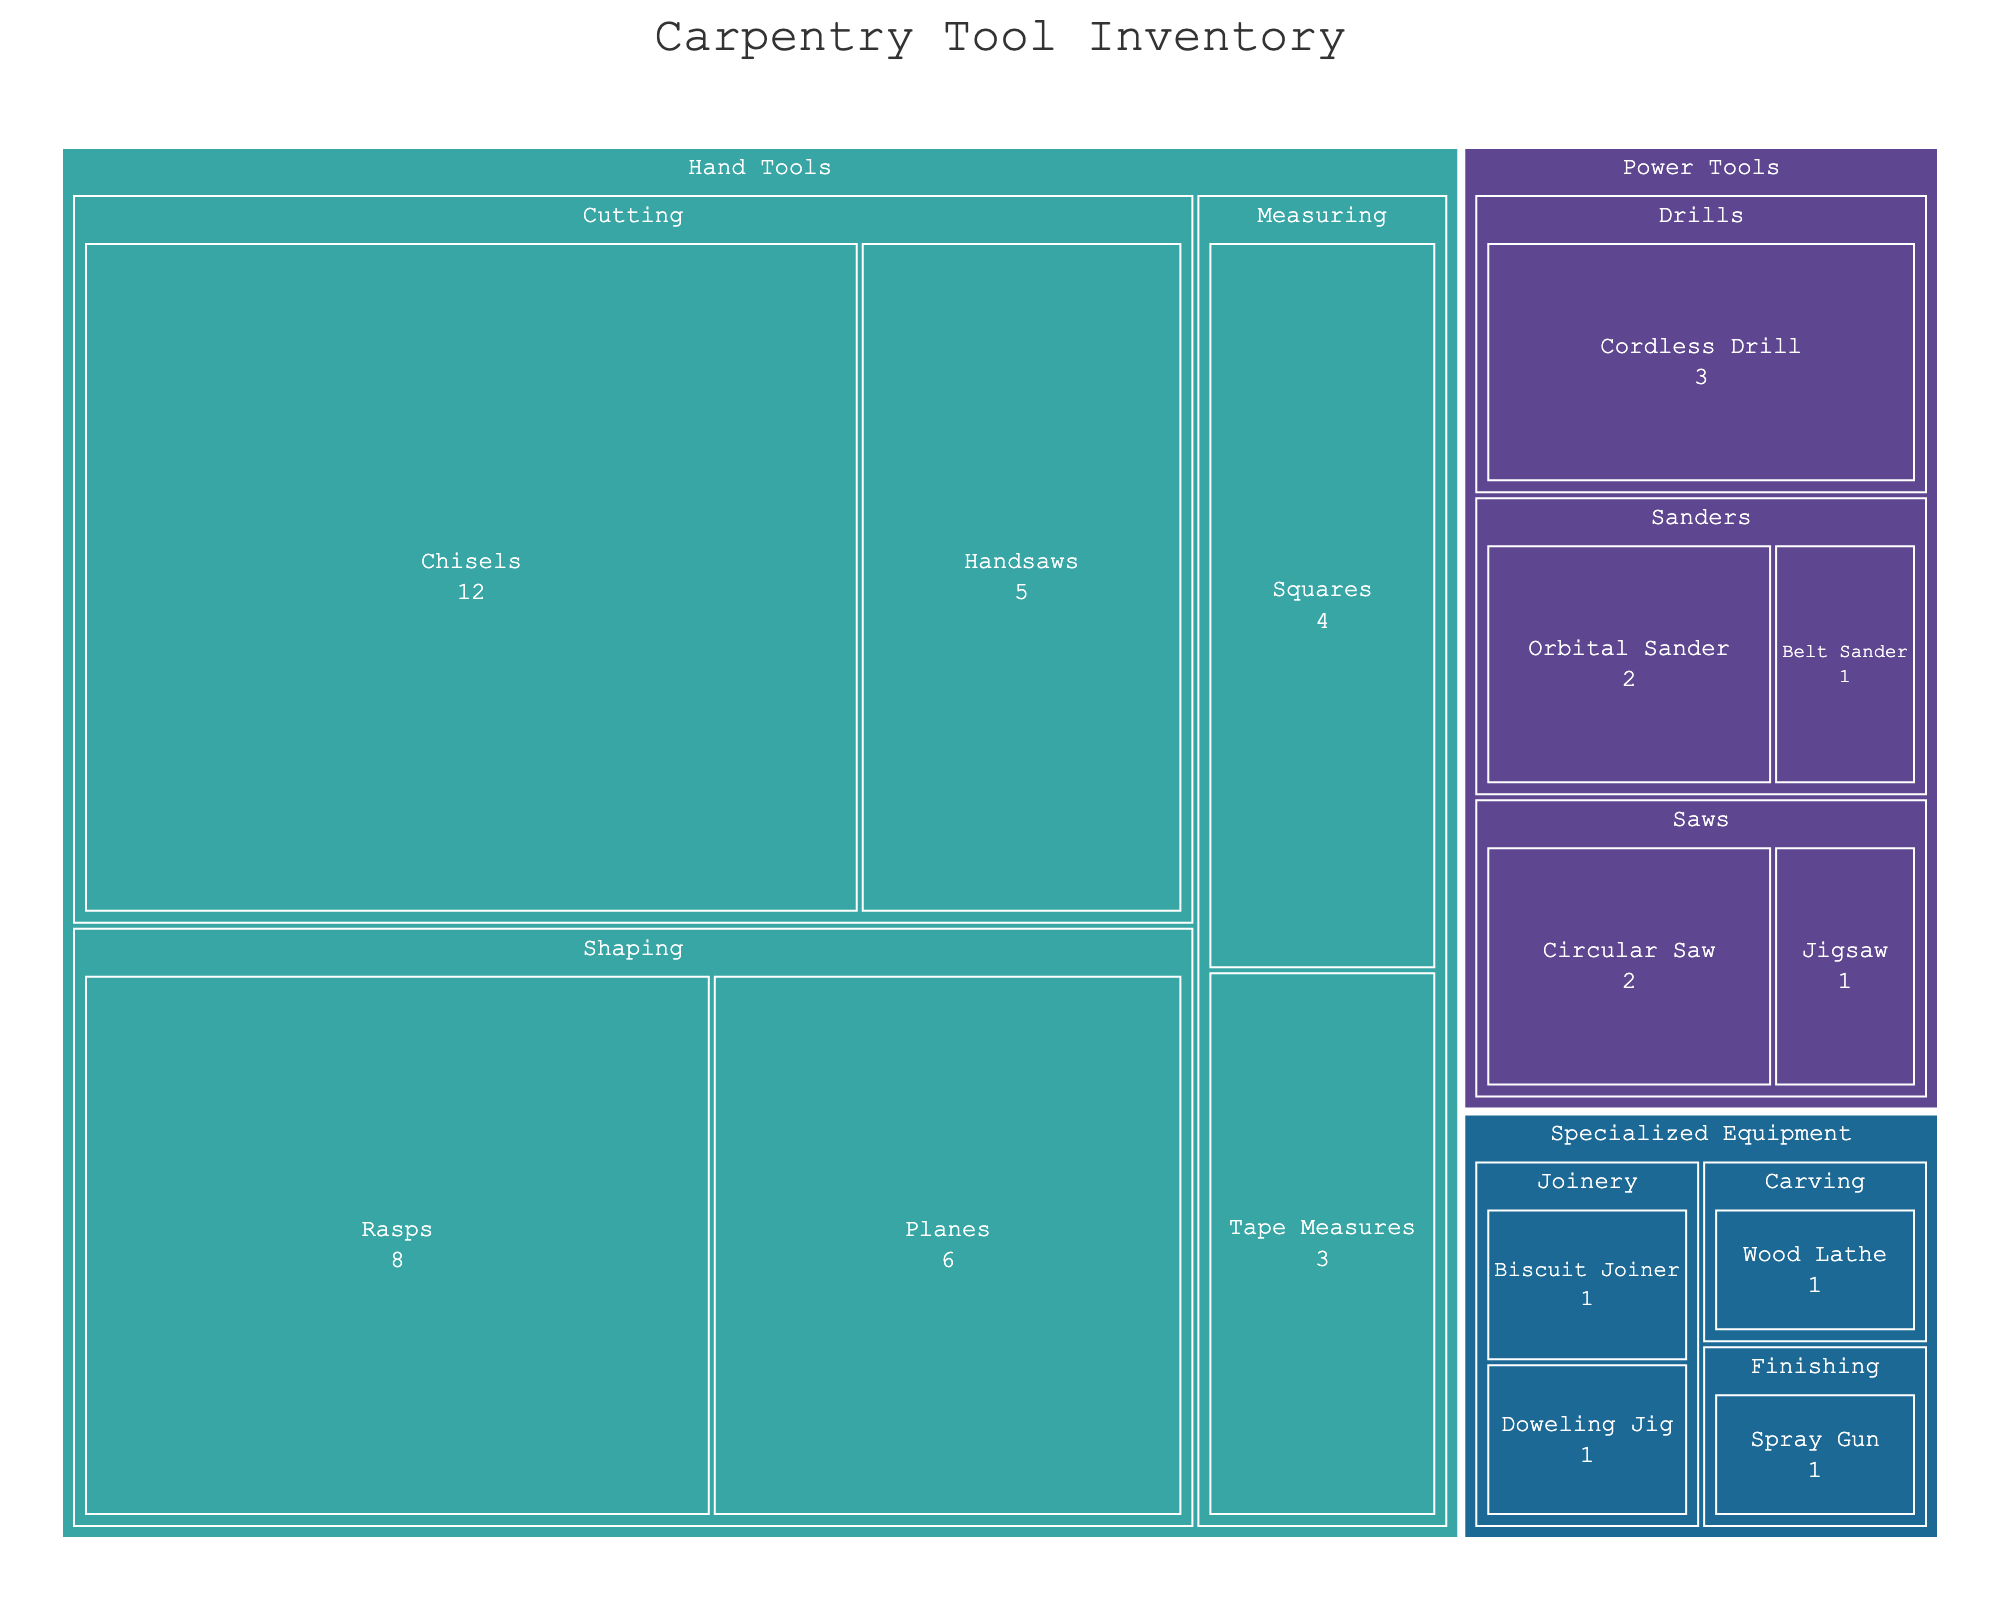what is the most common subcategory in the Hand Tools category? To find the most common subcategory in the Hand Tools category, you need to add up the quantities within each subcategory. Cutting has Handsaws (5) and Chisels (12) totaling 17; Measuring has Tape Measures (3) and Squares (4) totaling 7; Shaping has Planes (6) and Rasps (8) totaling 14. So, Cutting is the most common subcategory.
Answer: Cutting What is the least common item in the Power Tools category? Look at the quantities of each tool within the Power Tools category. Circular Saw (2), Jigsaw (1), Cordless Drill (3), Belt Sander (1), Orbital Sander (2). The least common items are Jigsaw and Belt Sander each with a quantity of 1.
Answer: Jigsaw and Belt Sander How many more Cutting tools are there compared to Shaping tools in the Hand Tools category? First, sum up the quantities of Cutting tools: Handsaws (5) and Chisels (12), which equals 17. Then, sum up the quantities of Shaping tools: Planes (6) and Rasps (8), which equals 14. The difference is 17 - 14 = 3 more Cutting tools.
Answer: 3 What percentage of the entire inventory does the Cordless Drill represent? To find the percentage, first sum up all the quantities across all categories. The total is 5 + 12 + 3 + 4 + 6 + 8 + 2 + 1 + 3 + 1 + 2 + 1 + 1 + 1 + 1 = 51. The quantity for the Cordless Drill is 3. The percentage is (3 / 51) * 100 ≈ 5.88%.
Answer: 5.88% Which category has the widest variety of tools? Look at the number of different tools in each category. Hand Tools: 6 tools (Handsaws, Chisels, Tape Measures, Squares, Planes, Rasps), Power Tools: 5 tools (Circular Saw, Jigsaw, Cordless Drill, Belt Sander, Orbital Sander), Specialized Equipment: 4 tools (Biscuit Joiner, Doweling Jig, Spray Gun, Wood Lathe). Hand Tools has the widest variety with 6 different tools.
Answer: Hand Tools Which category has the second-highest total quantity of tools? First, sum the quantities for each category. Hand Tools have 38 (5+12+3+4+6+8), Power Tools have 9 (2+1+3+1+2), and Specialized Equipment has 4 (1+1+1+1). The second-highest total quantity is Power Tools with 9.
Answer: Power Tools What is the least common subcategory overall? Evaluate the quantity sums of all subcategories. The subcategories with the lowest quantities are those in the Specialized Equipment category: Joinery (1+1 = 2), Finishing (1), Carving (1). Finishing and Carving tie for the least common overall with a quantity of 1 each.
Answer: Finishing and Carving 